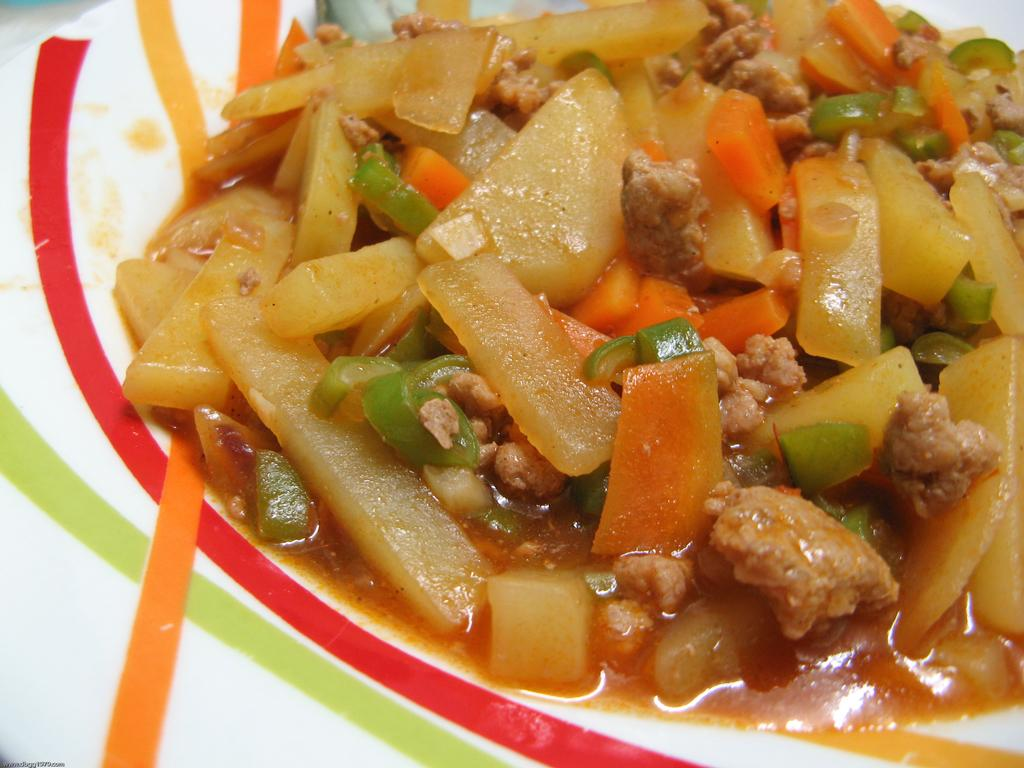What is present on the plate in the image? There is food in a plate in the image. What type of powder can be seen on the sidewalk near the plate of food in the image? There is no sidewalk or powder present in the image; it only features a plate of food. 